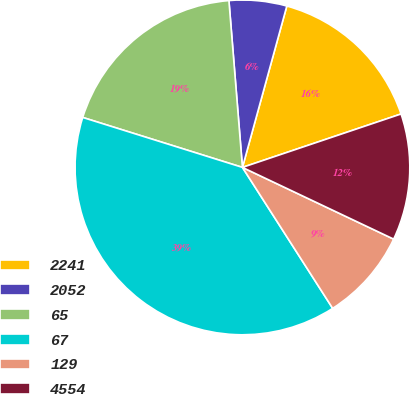Convert chart to OTSL. <chart><loc_0><loc_0><loc_500><loc_500><pie_chart><fcel>2241<fcel>2052<fcel>65<fcel>67<fcel>129<fcel>4554<nl><fcel>15.56%<fcel>5.56%<fcel>18.89%<fcel>38.89%<fcel>8.89%<fcel>12.22%<nl></chart> 